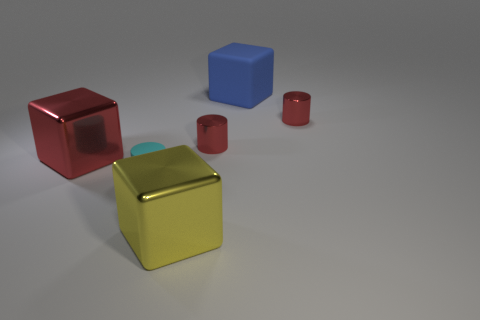Subtract all cyan blocks. Subtract all yellow spheres. How many blocks are left? 3 Add 2 tiny cyan matte objects. How many objects exist? 8 Add 6 big metallic things. How many big metallic things are left? 8 Add 2 small green cylinders. How many small green cylinders exist? 2 Subtract 1 blue blocks. How many objects are left? 5 Subtract all tiny rubber things. Subtract all cyan rubber objects. How many objects are left? 4 